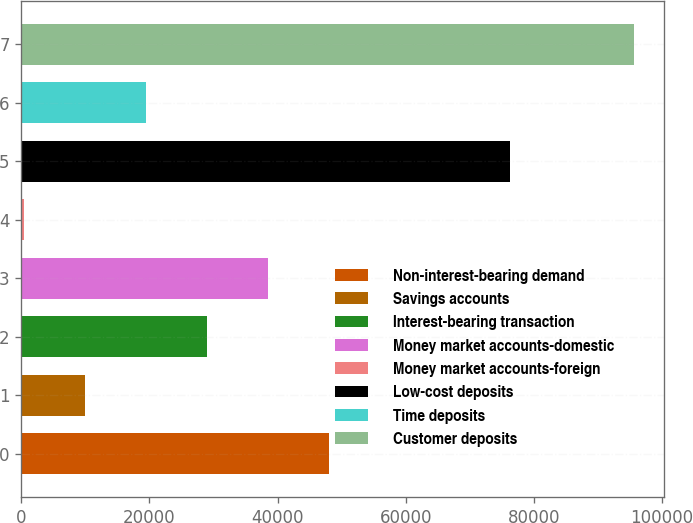Convert chart to OTSL. <chart><loc_0><loc_0><loc_500><loc_500><bar_chart><fcel>Non-interest-bearing demand<fcel>Savings accounts<fcel>Interest-bearing transaction<fcel>Money market accounts-domestic<fcel>Money market accounts-foreign<fcel>Low-cost deposits<fcel>Time deposits<fcel>Customer deposits<nl><fcel>48041<fcel>9976.2<fcel>29008.6<fcel>38524.8<fcel>460<fcel>76244<fcel>19492.4<fcel>95622<nl></chart> 